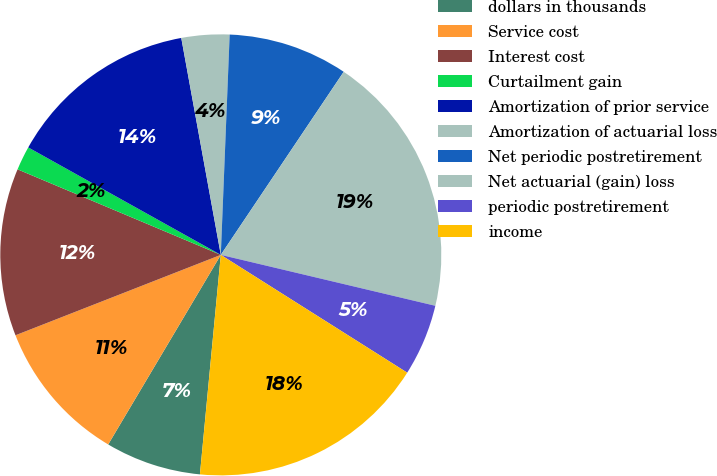Convert chart. <chart><loc_0><loc_0><loc_500><loc_500><pie_chart><fcel>dollars in thousands<fcel>Service cost<fcel>Interest cost<fcel>Curtailment gain<fcel>Amortization of prior service<fcel>Amortization of actuarial loss<fcel>Net periodic postretirement<fcel>Net actuarial (gain) loss<fcel>periodic postretirement<fcel>income<nl><fcel>7.02%<fcel>10.53%<fcel>12.28%<fcel>1.76%<fcel>14.03%<fcel>3.51%<fcel>8.77%<fcel>19.3%<fcel>5.26%<fcel>17.54%<nl></chart> 